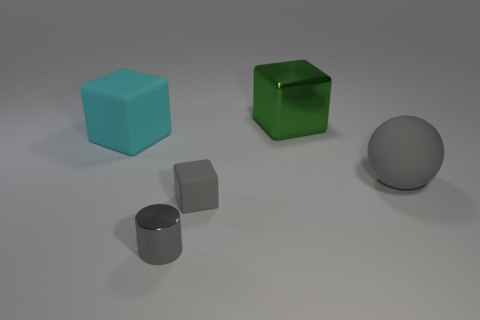Subtract all large blocks. How many blocks are left? 1 Add 4 small gray cubes. How many objects exist? 9 Subtract all tiny blue shiny spheres. Subtract all tiny gray rubber cubes. How many objects are left? 4 Add 5 metal blocks. How many metal blocks are left? 6 Add 3 brown rubber cylinders. How many brown rubber cylinders exist? 3 Subtract 0 brown balls. How many objects are left? 5 Subtract all cylinders. How many objects are left? 4 